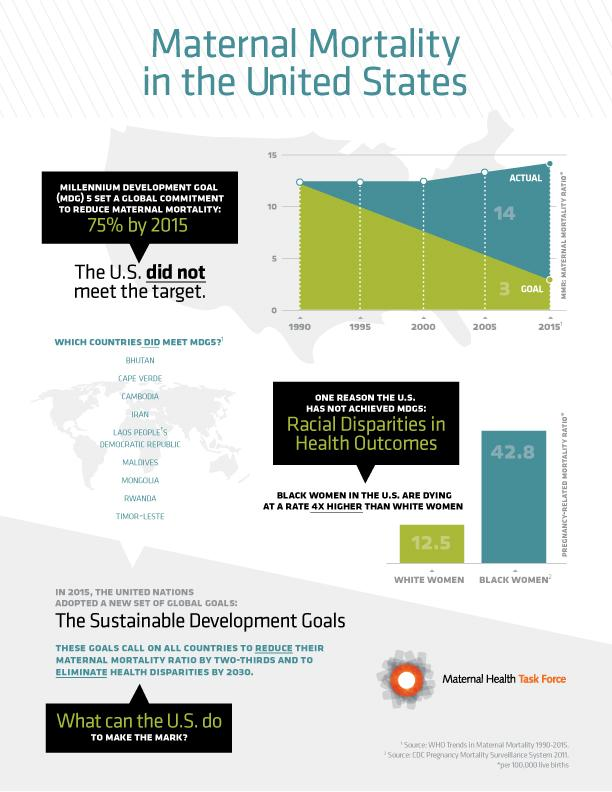List a handful of essential elements in this visual. The difference in the percentage of deaths between Black and White women is 30.3%. Nine countries met the Millennium Development Goal to reduce maternal mortality. 